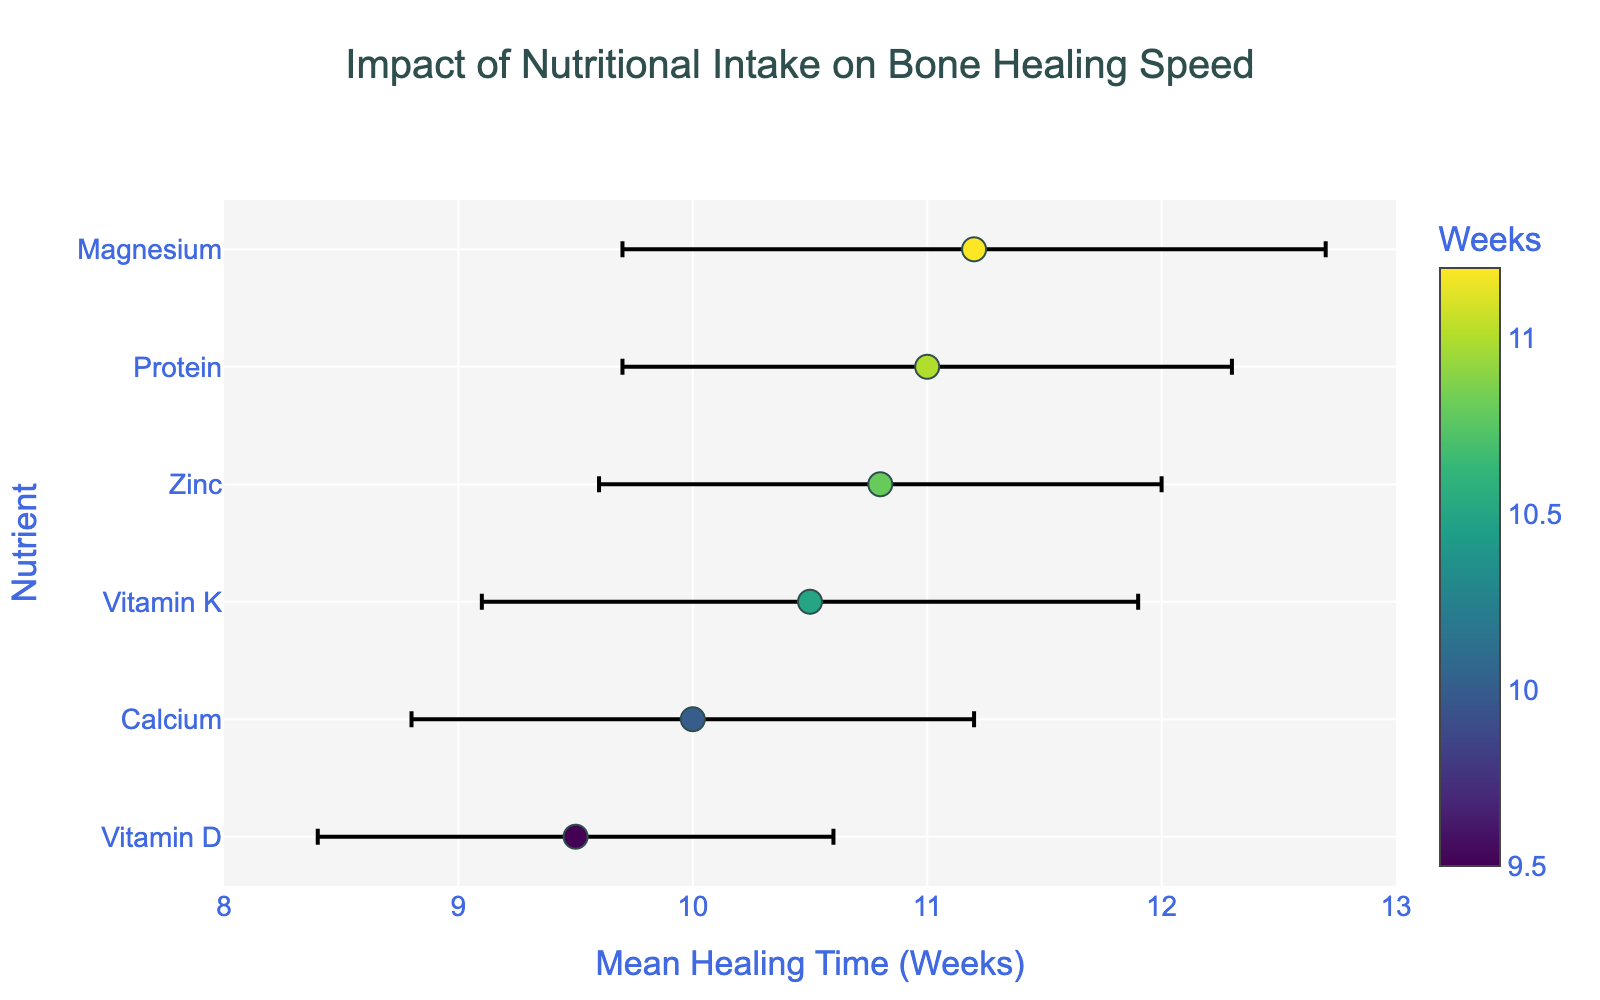What's the title of the plot? The title is located at the top of the plot. By looking at the top part of the figure, it's clear that the title reads "Impact of Nutritional Intake on Bone Healing Speed."
Answer: Impact of Nutritional Intake on Bone Healing Speed Which nutrient has the shortest mean healing time? To identify the shortest mean healing time, examine the x-axis where the mean healing times are plotted. The dot located at the furthest left corresponds to the shortest time. The nutrient associated with this dot is "Vitamin D."
Answer: Vitamin D Which nutrient has the longest mean healing time? The longest mean healing time can be found by looking at the dot furthest to the right on the x-axis. The nutrient associated with this dot is "Magnesium."
Answer: Magnesium What does the color of the markers represent? The color bar on the right side of the plot indicates that the color represents the mean healing time in weeks. Different shades on the color scale correspond to different mean healing times.
Answer: Mean Healing Time (Weeks) What is the error range for Protein? The error range for Protein can be found by looking at the error bars extending horizontally from the dot representing Protein. The mean healing time for Protein is 11 weeks with a standard deviation of 1.3 weeks, giving an error range of (11 - 1.3) to (11 + 1.3), which is 9.7 to 12.3 weeks.
Answer: 9.7 to 12.3 weeks How do the error bars for Calcium compare to those for Zinc? By looking at the length of the error bars for both Calcium and Zinc, it is evident that they are almost the same. Both error bars are relatively short, indicating similar and precise error measurements.
Answer: Similar error bars Which nutrient shows the greatest variability in healing times? The variability in healing times is represented by the length of the error bars. The nutrient with the longest error bar has the highest variability. In this plot, "Magnesium" has the longest error bar, indicating the greatest variability.
Answer: Magnesium What is the difference in mean healing time between Vitamin K and Calcium? The mean healing time for Vitamin K is 10.5 weeks and for Calcium is 10 weeks. The difference is calculated by subtracting the mean healing time of Calcium from that of Vitamin K, which is 10.5 - 10 = 0.5 weeks.
Answer: 0.5 weeks What is the average mean healing time for all the nutrients listed? To find the average, sum up the mean healing times for all nutrients and divide by the number of nutrients. The mean healing times are 10, 9.5, 11, 10.5, 11.2, and 10.8. Summing these gives 63, and dividing by 6 gives 63/6 = 10.5 weeks.
Answer: 10.5 weeks Which nutrient has a mean healing time that is closest to the overall average? The overall average mean healing time is 10.5 weeks. By comparing each nutrient's mean healing time to 10.5 weeks, "Vitamin K" has a mean healing time of 10.5 weeks.
Answer: Vitamin K 